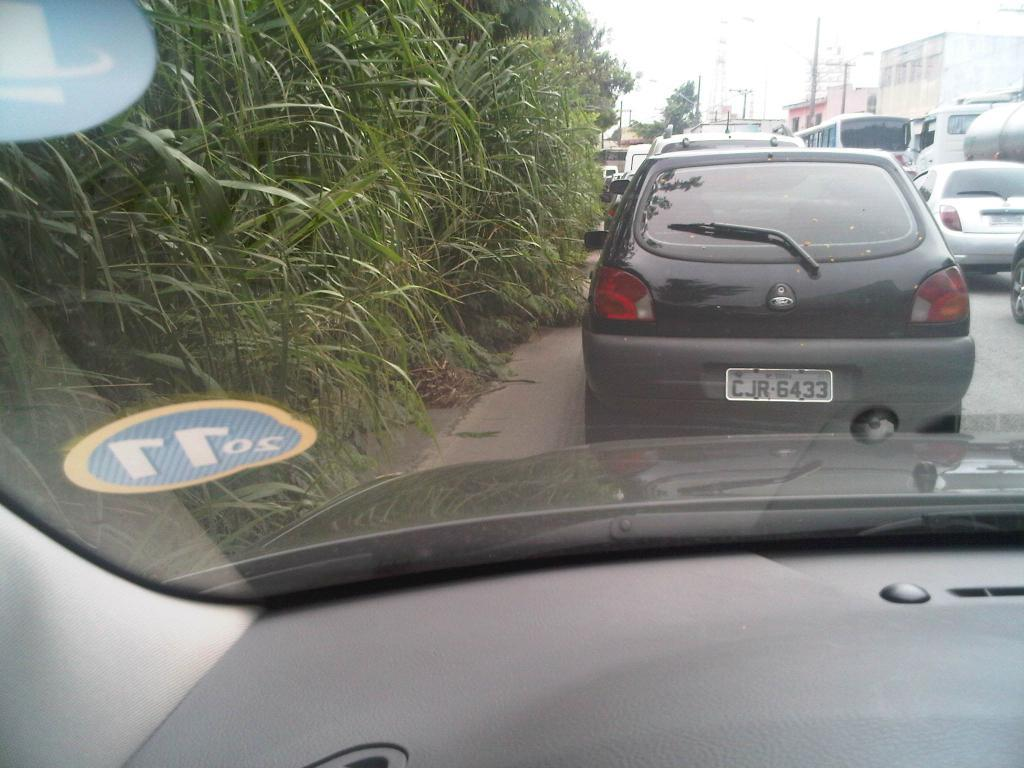Provide a one-sentence caption for the provided image. White license plate on a car which says CJR6433. 